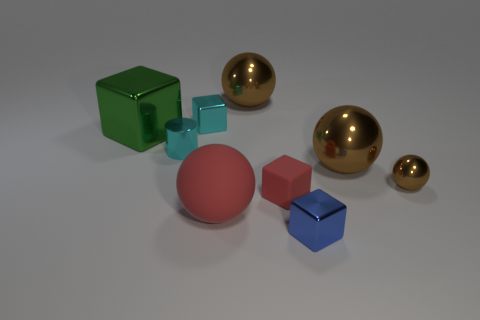Is the color of the matte sphere the same as the tiny matte thing?
Your answer should be compact. Yes. There is a object that is the same color as the cylinder; what size is it?
Make the answer very short. Small. Are there any tiny brown cylinders made of the same material as the big green block?
Your answer should be very brief. No. Do the green cube and the big red thing have the same material?
Your answer should be very brief. No. There is a block that is the same size as the red ball; what is its color?
Your answer should be compact. Green. What number of other things are there of the same shape as the small blue metallic thing?
Offer a very short reply. 3. There is a cylinder; is it the same size as the block behind the large metallic block?
Provide a short and direct response. Yes. What number of things are either big green rubber things or big green metallic blocks?
Ensure brevity in your answer.  1. How many other things are there of the same size as the red sphere?
Keep it short and to the point. 3. Is the color of the tiny metallic ball the same as the big metal ball that is in front of the tiny cylinder?
Offer a very short reply. Yes. 